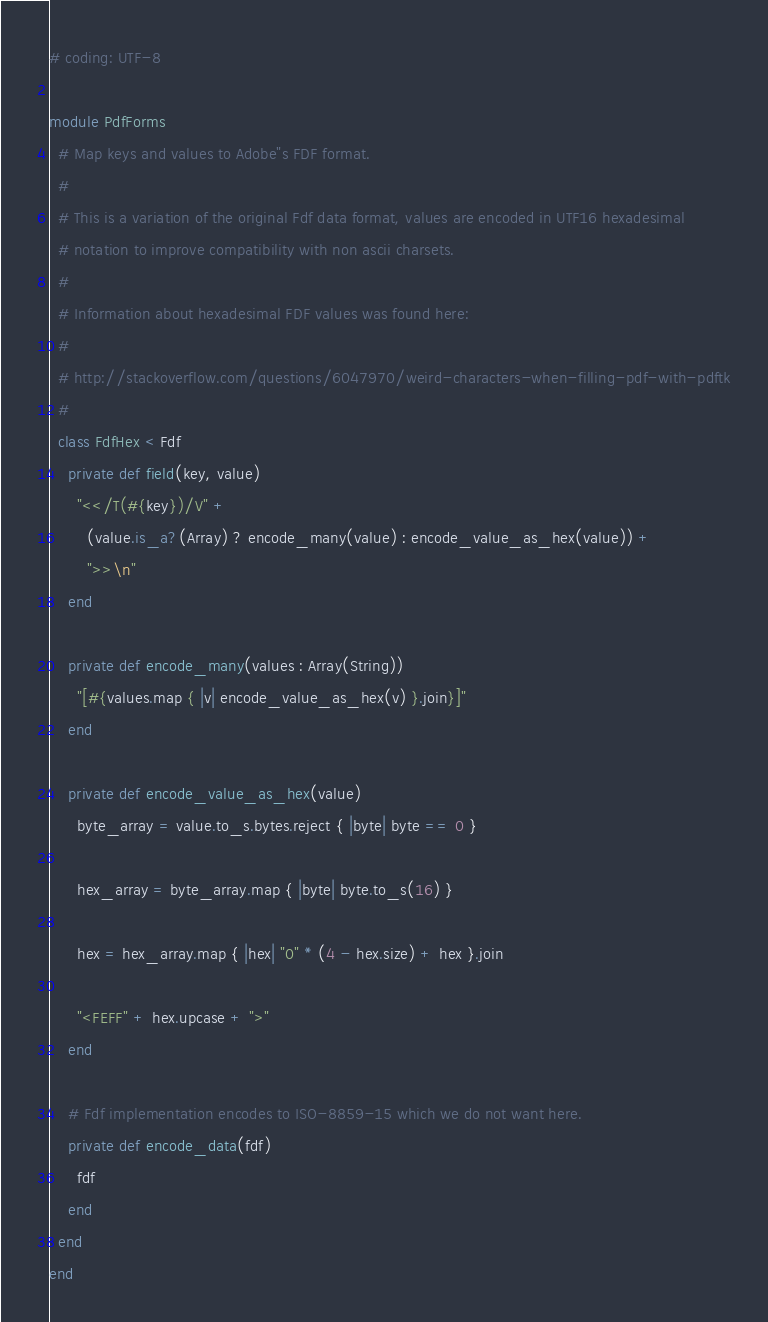<code> <loc_0><loc_0><loc_500><loc_500><_Crystal_># coding: UTF-8

module PdfForms
  # Map keys and values to Adobe"s FDF format.
  #
  # This is a variation of the original Fdf data format, values are encoded in UTF16 hexadesimal
  # notation to improve compatibility with non ascii charsets.
  #
  # Information about hexadesimal FDF values was found here:
  #
  # http://stackoverflow.com/questions/6047970/weird-characters-when-filling-pdf-with-pdftk
  #
  class FdfHex < Fdf
    private def field(key, value)
      "<</T(#{key})/V" +
        (value.is_a?(Array) ? encode_many(value) : encode_value_as_hex(value)) +
        ">>\n"
    end

    private def encode_many(values : Array(String))
      "[#{values.map { |v| encode_value_as_hex(v) }.join}]"
    end

    private def encode_value_as_hex(value)
      byte_array = value.to_s.bytes.reject { |byte| byte == 0 }

      hex_array = byte_array.map { |byte| byte.to_s(16) }

      hex = hex_array.map { |hex| "0" * (4 - hex.size) + hex }.join

      "<FEFF" + hex.upcase + ">"
    end

    # Fdf implementation encodes to ISO-8859-15 which we do not want here.
    private def encode_data(fdf)
      fdf
    end
  end
end
</code> 